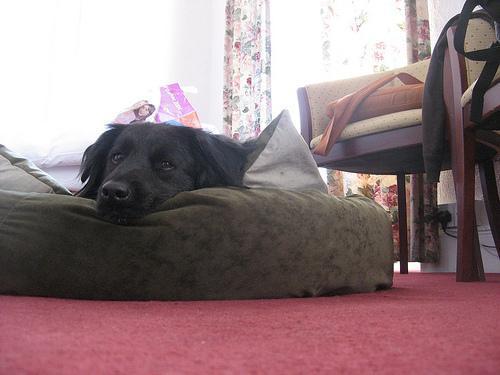How many dogs are there?
Give a very brief answer. 1. 